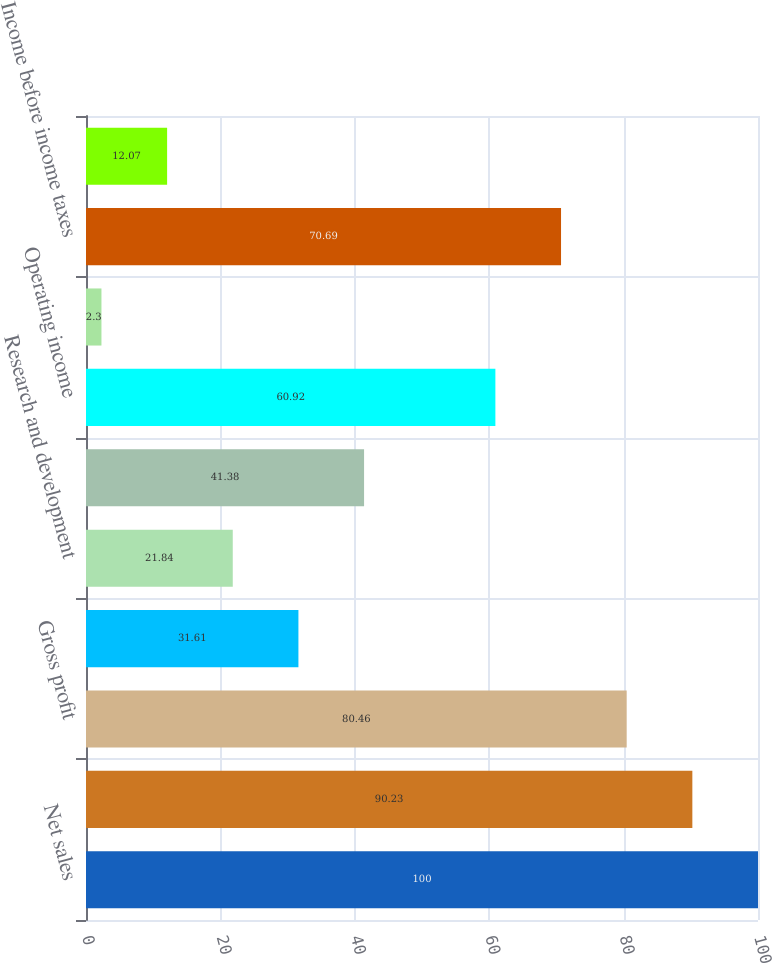<chart> <loc_0><loc_0><loc_500><loc_500><bar_chart><fcel>Net sales<fcel>Cost of goods sold<fcel>Gross profit<fcel>Selling general and<fcel>Research and development<fcel>Total operating expenses<fcel>Operating income<fcel>Other income / (expense) net<fcel>Income before income taxes<fcel>Provision for income taxes<nl><fcel>100<fcel>90.23<fcel>80.46<fcel>31.61<fcel>21.84<fcel>41.38<fcel>60.92<fcel>2.3<fcel>70.69<fcel>12.07<nl></chart> 